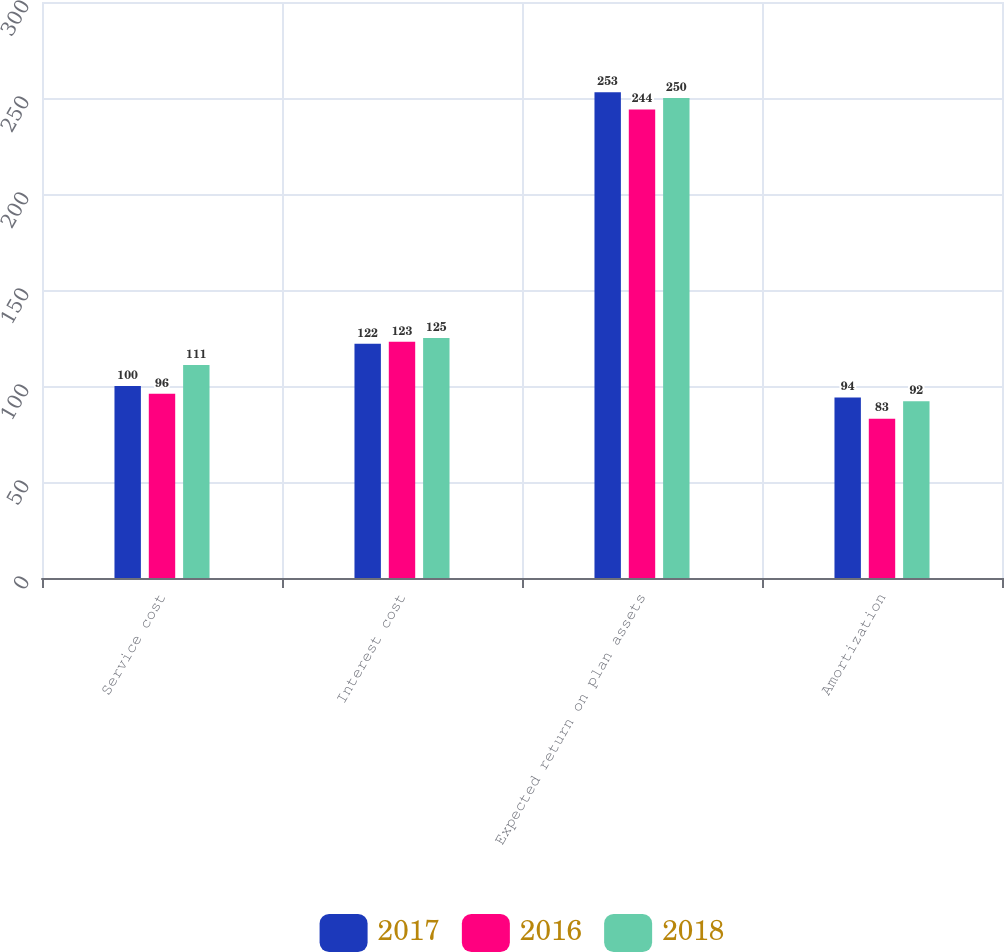Convert chart. <chart><loc_0><loc_0><loc_500><loc_500><stacked_bar_chart><ecel><fcel>Service cost<fcel>Interest cost<fcel>Expected return on plan assets<fcel>Amortization<nl><fcel>2017<fcel>100<fcel>122<fcel>253<fcel>94<nl><fcel>2016<fcel>96<fcel>123<fcel>244<fcel>83<nl><fcel>2018<fcel>111<fcel>125<fcel>250<fcel>92<nl></chart> 